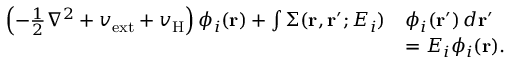Convert formula to latex. <formula><loc_0><loc_0><loc_500><loc_500>\begin{array} { r l } { \left ( - \frac { 1 } { 2 } \nabla ^ { 2 } + v _ { e x t } + v _ { H } \right ) \phi _ { i } ( r ) + \int \Sigma ( r , r ^ { \prime } ; E _ { i } ) } & { \phi _ { i } ( r ^ { \prime } ) \, d r ^ { \prime } } \\ & { = E _ { i } \phi _ { i } ( r ) . } \end{array}</formula> 